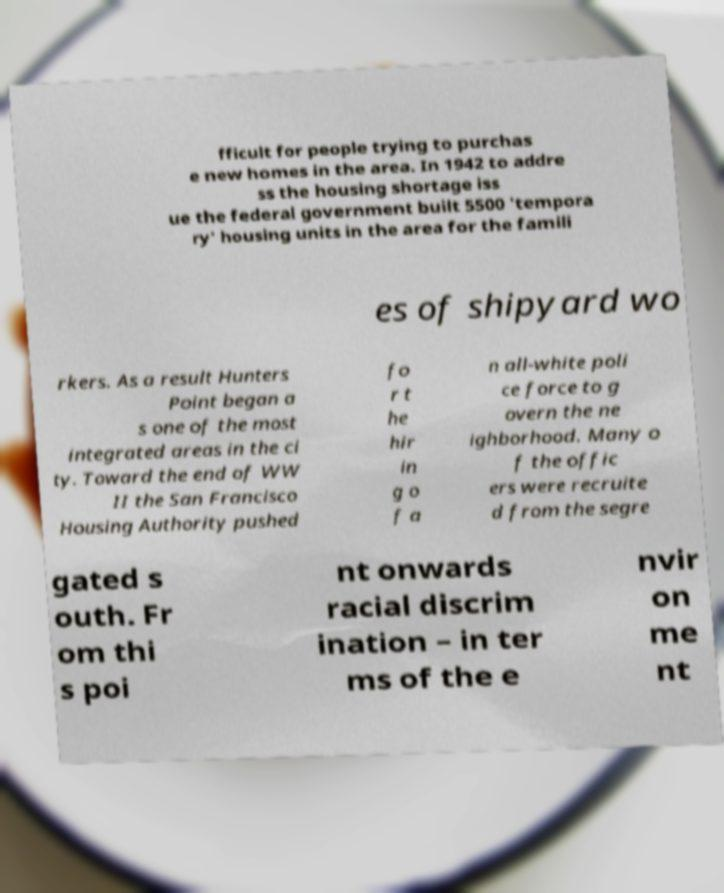For documentation purposes, I need the text within this image transcribed. Could you provide that? fficult for people trying to purchas e new homes in the area. In 1942 to addre ss the housing shortage iss ue the federal government built 5500 'tempora ry' housing units in the area for the famili es of shipyard wo rkers. As a result Hunters Point began a s one of the most integrated areas in the ci ty. Toward the end of WW II the San Francisco Housing Authority pushed fo r t he hir in g o f a n all-white poli ce force to g overn the ne ighborhood. Many o f the offic ers were recruite d from the segre gated s outh. Fr om thi s poi nt onwards racial discrim ination – in ter ms of the e nvir on me nt 